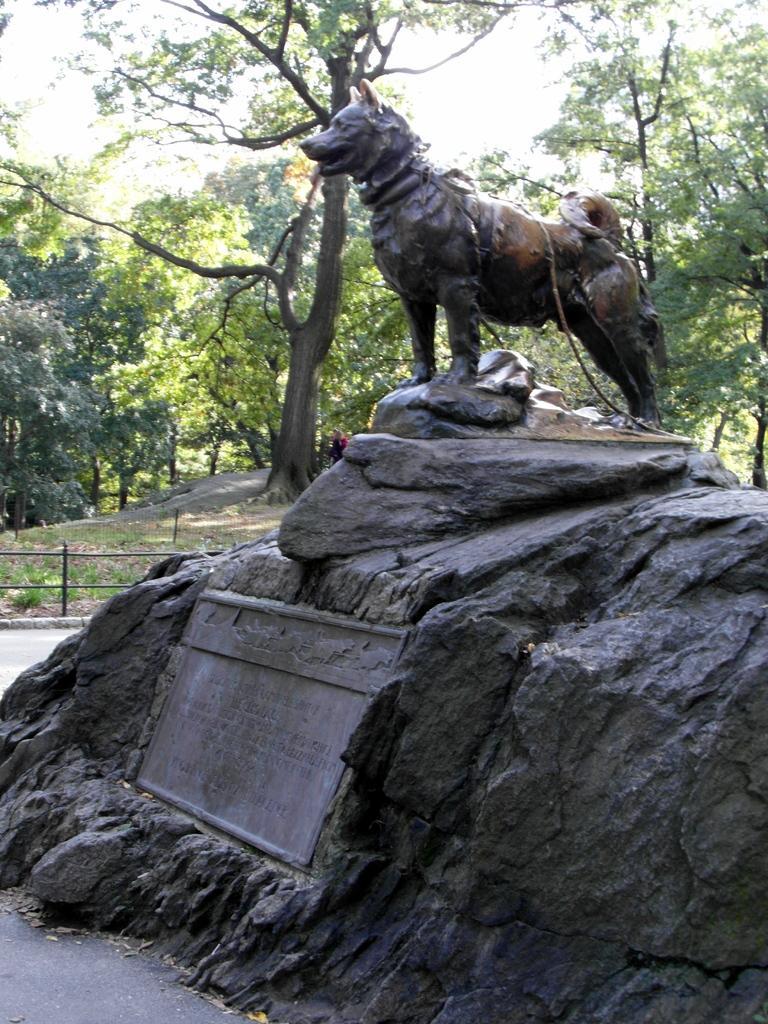Describe this image in one or two sentences. This image consists of a sculpture of a dog made up of rock. At the bottom, there is a memorial stone. In the background, there are trees. At the top, there is a sky. 